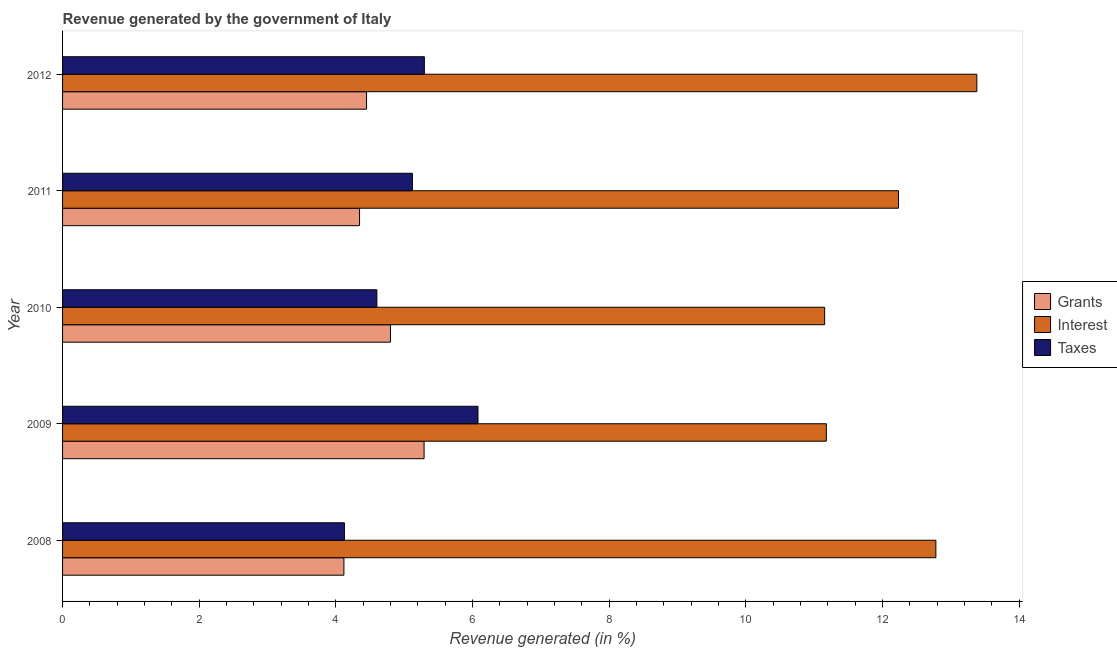How many different coloured bars are there?
Your response must be concise. 3. How many groups of bars are there?
Your response must be concise. 5. Are the number of bars on each tick of the Y-axis equal?
Offer a very short reply. Yes. How many bars are there on the 5th tick from the top?
Give a very brief answer. 3. What is the label of the 4th group of bars from the top?
Offer a very short reply. 2009. In how many cases, is the number of bars for a given year not equal to the number of legend labels?
Provide a succinct answer. 0. What is the percentage of revenue generated by interest in 2010?
Your response must be concise. 11.16. Across all years, what is the maximum percentage of revenue generated by interest?
Ensure brevity in your answer.  13.38. Across all years, what is the minimum percentage of revenue generated by interest?
Keep it short and to the point. 11.16. In which year was the percentage of revenue generated by interest maximum?
Offer a very short reply. 2012. What is the total percentage of revenue generated by grants in the graph?
Give a very brief answer. 23.01. What is the difference between the percentage of revenue generated by taxes in 2009 and that in 2012?
Ensure brevity in your answer.  0.79. What is the difference between the percentage of revenue generated by interest in 2010 and the percentage of revenue generated by taxes in 2008?
Offer a terse response. 7.03. What is the average percentage of revenue generated by grants per year?
Keep it short and to the point. 4.6. In the year 2010, what is the difference between the percentage of revenue generated by taxes and percentage of revenue generated by grants?
Your answer should be very brief. -0.2. What is the ratio of the percentage of revenue generated by interest in 2008 to that in 2012?
Offer a terse response. 0.95. Is the percentage of revenue generated by grants in 2008 less than that in 2012?
Your answer should be very brief. Yes. Is the difference between the percentage of revenue generated by interest in 2008 and 2011 greater than the difference between the percentage of revenue generated by taxes in 2008 and 2011?
Provide a succinct answer. Yes. What is the difference between the highest and the second highest percentage of revenue generated by taxes?
Provide a short and direct response. 0.79. What is the difference between the highest and the lowest percentage of revenue generated by interest?
Your response must be concise. 2.23. In how many years, is the percentage of revenue generated by grants greater than the average percentage of revenue generated by grants taken over all years?
Your response must be concise. 2. What does the 1st bar from the top in 2010 represents?
Ensure brevity in your answer.  Taxes. What does the 3rd bar from the bottom in 2009 represents?
Make the answer very short. Taxes. Is it the case that in every year, the sum of the percentage of revenue generated by grants and percentage of revenue generated by interest is greater than the percentage of revenue generated by taxes?
Your answer should be compact. Yes. Are the values on the major ticks of X-axis written in scientific E-notation?
Offer a very short reply. No. How are the legend labels stacked?
Provide a succinct answer. Vertical. What is the title of the graph?
Your answer should be very brief. Revenue generated by the government of Italy. What is the label or title of the X-axis?
Keep it short and to the point. Revenue generated (in %). What is the label or title of the Y-axis?
Provide a succinct answer. Year. What is the Revenue generated (in %) in Grants in 2008?
Offer a terse response. 4.12. What is the Revenue generated (in %) of Interest in 2008?
Your response must be concise. 12.78. What is the Revenue generated (in %) in Taxes in 2008?
Make the answer very short. 4.13. What is the Revenue generated (in %) in Grants in 2009?
Provide a succinct answer. 5.29. What is the Revenue generated (in %) in Interest in 2009?
Ensure brevity in your answer.  11.18. What is the Revenue generated (in %) in Taxes in 2009?
Your answer should be very brief. 6.08. What is the Revenue generated (in %) of Grants in 2010?
Ensure brevity in your answer.  4.8. What is the Revenue generated (in %) in Interest in 2010?
Provide a succinct answer. 11.16. What is the Revenue generated (in %) in Taxes in 2010?
Give a very brief answer. 4.6. What is the Revenue generated (in %) of Grants in 2011?
Give a very brief answer. 4.35. What is the Revenue generated (in %) in Interest in 2011?
Provide a short and direct response. 12.24. What is the Revenue generated (in %) of Taxes in 2011?
Your response must be concise. 5.12. What is the Revenue generated (in %) in Grants in 2012?
Offer a very short reply. 4.45. What is the Revenue generated (in %) of Interest in 2012?
Keep it short and to the point. 13.38. What is the Revenue generated (in %) of Taxes in 2012?
Ensure brevity in your answer.  5.3. Across all years, what is the maximum Revenue generated (in %) in Grants?
Provide a short and direct response. 5.29. Across all years, what is the maximum Revenue generated (in %) in Interest?
Ensure brevity in your answer.  13.38. Across all years, what is the maximum Revenue generated (in %) of Taxes?
Your answer should be very brief. 6.08. Across all years, what is the minimum Revenue generated (in %) in Grants?
Your response must be concise. 4.12. Across all years, what is the minimum Revenue generated (in %) in Interest?
Give a very brief answer. 11.16. Across all years, what is the minimum Revenue generated (in %) of Taxes?
Your answer should be very brief. 4.13. What is the total Revenue generated (in %) of Grants in the graph?
Your answer should be compact. 23.01. What is the total Revenue generated (in %) of Interest in the graph?
Keep it short and to the point. 60.74. What is the total Revenue generated (in %) of Taxes in the graph?
Make the answer very short. 25.22. What is the difference between the Revenue generated (in %) in Grants in 2008 and that in 2009?
Offer a very short reply. -1.17. What is the difference between the Revenue generated (in %) of Interest in 2008 and that in 2009?
Provide a succinct answer. 1.6. What is the difference between the Revenue generated (in %) of Taxes in 2008 and that in 2009?
Offer a terse response. -1.96. What is the difference between the Revenue generated (in %) in Grants in 2008 and that in 2010?
Your response must be concise. -0.68. What is the difference between the Revenue generated (in %) in Interest in 2008 and that in 2010?
Your answer should be compact. 1.63. What is the difference between the Revenue generated (in %) in Taxes in 2008 and that in 2010?
Provide a short and direct response. -0.48. What is the difference between the Revenue generated (in %) in Grants in 2008 and that in 2011?
Your response must be concise. -0.23. What is the difference between the Revenue generated (in %) of Interest in 2008 and that in 2011?
Ensure brevity in your answer.  0.55. What is the difference between the Revenue generated (in %) of Taxes in 2008 and that in 2011?
Your answer should be very brief. -1. What is the difference between the Revenue generated (in %) in Grants in 2008 and that in 2012?
Your answer should be compact. -0.33. What is the difference between the Revenue generated (in %) of Interest in 2008 and that in 2012?
Provide a succinct answer. -0.6. What is the difference between the Revenue generated (in %) of Taxes in 2008 and that in 2012?
Keep it short and to the point. -1.17. What is the difference between the Revenue generated (in %) in Grants in 2009 and that in 2010?
Keep it short and to the point. 0.49. What is the difference between the Revenue generated (in %) in Interest in 2009 and that in 2010?
Make the answer very short. 0.02. What is the difference between the Revenue generated (in %) in Taxes in 2009 and that in 2010?
Your answer should be very brief. 1.48. What is the difference between the Revenue generated (in %) in Grants in 2009 and that in 2011?
Provide a short and direct response. 0.94. What is the difference between the Revenue generated (in %) of Interest in 2009 and that in 2011?
Your answer should be compact. -1.06. What is the difference between the Revenue generated (in %) of Taxes in 2009 and that in 2011?
Provide a short and direct response. 0.96. What is the difference between the Revenue generated (in %) of Grants in 2009 and that in 2012?
Provide a short and direct response. 0.84. What is the difference between the Revenue generated (in %) in Interest in 2009 and that in 2012?
Ensure brevity in your answer.  -2.2. What is the difference between the Revenue generated (in %) of Taxes in 2009 and that in 2012?
Give a very brief answer. 0.79. What is the difference between the Revenue generated (in %) in Grants in 2010 and that in 2011?
Your response must be concise. 0.45. What is the difference between the Revenue generated (in %) of Interest in 2010 and that in 2011?
Your answer should be very brief. -1.08. What is the difference between the Revenue generated (in %) in Taxes in 2010 and that in 2011?
Provide a succinct answer. -0.52. What is the difference between the Revenue generated (in %) in Grants in 2010 and that in 2012?
Provide a short and direct response. 0.35. What is the difference between the Revenue generated (in %) of Interest in 2010 and that in 2012?
Offer a very short reply. -2.23. What is the difference between the Revenue generated (in %) in Taxes in 2010 and that in 2012?
Your answer should be compact. -0.69. What is the difference between the Revenue generated (in %) of Grants in 2011 and that in 2012?
Offer a very short reply. -0.1. What is the difference between the Revenue generated (in %) in Interest in 2011 and that in 2012?
Provide a succinct answer. -1.15. What is the difference between the Revenue generated (in %) in Taxes in 2011 and that in 2012?
Ensure brevity in your answer.  -0.17. What is the difference between the Revenue generated (in %) of Grants in 2008 and the Revenue generated (in %) of Interest in 2009?
Offer a very short reply. -7.06. What is the difference between the Revenue generated (in %) of Grants in 2008 and the Revenue generated (in %) of Taxes in 2009?
Provide a short and direct response. -1.96. What is the difference between the Revenue generated (in %) of Interest in 2008 and the Revenue generated (in %) of Taxes in 2009?
Keep it short and to the point. 6.7. What is the difference between the Revenue generated (in %) of Grants in 2008 and the Revenue generated (in %) of Interest in 2010?
Ensure brevity in your answer.  -7.04. What is the difference between the Revenue generated (in %) of Grants in 2008 and the Revenue generated (in %) of Taxes in 2010?
Give a very brief answer. -0.48. What is the difference between the Revenue generated (in %) in Interest in 2008 and the Revenue generated (in %) in Taxes in 2010?
Offer a terse response. 8.18. What is the difference between the Revenue generated (in %) of Grants in 2008 and the Revenue generated (in %) of Interest in 2011?
Offer a terse response. -8.12. What is the difference between the Revenue generated (in %) of Grants in 2008 and the Revenue generated (in %) of Taxes in 2011?
Your answer should be very brief. -1. What is the difference between the Revenue generated (in %) in Interest in 2008 and the Revenue generated (in %) in Taxes in 2011?
Provide a short and direct response. 7.66. What is the difference between the Revenue generated (in %) in Grants in 2008 and the Revenue generated (in %) in Interest in 2012?
Give a very brief answer. -9.26. What is the difference between the Revenue generated (in %) in Grants in 2008 and the Revenue generated (in %) in Taxes in 2012?
Your answer should be very brief. -1.18. What is the difference between the Revenue generated (in %) in Interest in 2008 and the Revenue generated (in %) in Taxes in 2012?
Make the answer very short. 7.49. What is the difference between the Revenue generated (in %) in Grants in 2009 and the Revenue generated (in %) in Interest in 2010?
Provide a succinct answer. -5.86. What is the difference between the Revenue generated (in %) in Grants in 2009 and the Revenue generated (in %) in Taxes in 2010?
Keep it short and to the point. 0.69. What is the difference between the Revenue generated (in %) in Interest in 2009 and the Revenue generated (in %) in Taxes in 2010?
Your response must be concise. 6.58. What is the difference between the Revenue generated (in %) of Grants in 2009 and the Revenue generated (in %) of Interest in 2011?
Your response must be concise. -6.94. What is the difference between the Revenue generated (in %) in Grants in 2009 and the Revenue generated (in %) in Taxes in 2011?
Give a very brief answer. 0.17. What is the difference between the Revenue generated (in %) of Interest in 2009 and the Revenue generated (in %) of Taxes in 2011?
Provide a succinct answer. 6.06. What is the difference between the Revenue generated (in %) of Grants in 2009 and the Revenue generated (in %) of Interest in 2012?
Offer a terse response. -8.09. What is the difference between the Revenue generated (in %) of Grants in 2009 and the Revenue generated (in %) of Taxes in 2012?
Make the answer very short. -0. What is the difference between the Revenue generated (in %) in Interest in 2009 and the Revenue generated (in %) in Taxes in 2012?
Provide a succinct answer. 5.88. What is the difference between the Revenue generated (in %) in Grants in 2010 and the Revenue generated (in %) in Interest in 2011?
Keep it short and to the point. -7.44. What is the difference between the Revenue generated (in %) in Grants in 2010 and the Revenue generated (in %) in Taxes in 2011?
Your answer should be compact. -0.32. What is the difference between the Revenue generated (in %) of Interest in 2010 and the Revenue generated (in %) of Taxes in 2011?
Ensure brevity in your answer.  6.03. What is the difference between the Revenue generated (in %) of Grants in 2010 and the Revenue generated (in %) of Interest in 2012?
Ensure brevity in your answer.  -8.58. What is the difference between the Revenue generated (in %) of Grants in 2010 and the Revenue generated (in %) of Taxes in 2012?
Offer a very short reply. -0.5. What is the difference between the Revenue generated (in %) of Interest in 2010 and the Revenue generated (in %) of Taxes in 2012?
Your answer should be very brief. 5.86. What is the difference between the Revenue generated (in %) of Grants in 2011 and the Revenue generated (in %) of Interest in 2012?
Your answer should be very brief. -9.04. What is the difference between the Revenue generated (in %) of Grants in 2011 and the Revenue generated (in %) of Taxes in 2012?
Ensure brevity in your answer.  -0.95. What is the difference between the Revenue generated (in %) of Interest in 2011 and the Revenue generated (in %) of Taxes in 2012?
Your answer should be very brief. 6.94. What is the average Revenue generated (in %) of Grants per year?
Provide a succinct answer. 4.6. What is the average Revenue generated (in %) of Interest per year?
Offer a terse response. 12.15. What is the average Revenue generated (in %) of Taxes per year?
Keep it short and to the point. 5.04. In the year 2008, what is the difference between the Revenue generated (in %) in Grants and Revenue generated (in %) in Interest?
Offer a very short reply. -8.66. In the year 2008, what is the difference between the Revenue generated (in %) in Grants and Revenue generated (in %) in Taxes?
Your response must be concise. -0.01. In the year 2008, what is the difference between the Revenue generated (in %) of Interest and Revenue generated (in %) of Taxes?
Keep it short and to the point. 8.66. In the year 2009, what is the difference between the Revenue generated (in %) of Grants and Revenue generated (in %) of Interest?
Offer a very short reply. -5.89. In the year 2009, what is the difference between the Revenue generated (in %) in Grants and Revenue generated (in %) in Taxes?
Ensure brevity in your answer.  -0.79. In the year 2009, what is the difference between the Revenue generated (in %) in Interest and Revenue generated (in %) in Taxes?
Provide a short and direct response. 5.1. In the year 2010, what is the difference between the Revenue generated (in %) of Grants and Revenue generated (in %) of Interest?
Your answer should be very brief. -6.36. In the year 2010, what is the difference between the Revenue generated (in %) in Grants and Revenue generated (in %) in Taxes?
Provide a short and direct response. 0.2. In the year 2010, what is the difference between the Revenue generated (in %) of Interest and Revenue generated (in %) of Taxes?
Your answer should be compact. 6.55. In the year 2011, what is the difference between the Revenue generated (in %) of Grants and Revenue generated (in %) of Interest?
Your answer should be compact. -7.89. In the year 2011, what is the difference between the Revenue generated (in %) of Grants and Revenue generated (in %) of Taxes?
Your answer should be very brief. -0.77. In the year 2011, what is the difference between the Revenue generated (in %) in Interest and Revenue generated (in %) in Taxes?
Your answer should be compact. 7.12. In the year 2012, what is the difference between the Revenue generated (in %) in Grants and Revenue generated (in %) in Interest?
Keep it short and to the point. -8.93. In the year 2012, what is the difference between the Revenue generated (in %) in Grants and Revenue generated (in %) in Taxes?
Give a very brief answer. -0.85. In the year 2012, what is the difference between the Revenue generated (in %) of Interest and Revenue generated (in %) of Taxes?
Your answer should be compact. 8.09. What is the ratio of the Revenue generated (in %) of Grants in 2008 to that in 2009?
Ensure brevity in your answer.  0.78. What is the ratio of the Revenue generated (in %) of Interest in 2008 to that in 2009?
Keep it short and to the point. 1.14. What is the ratio of the Revenue generated (in %) of Taxes in 2008 to that in 2009?
Your answer should be compact. 0.68. What is the ratio of the Revenue generated (in %) in Grants in 2008 to that in 2010?
Give a very brief answer. 0.86. What is the ratio of the Revenue generated (in %) in Interest in 2008 to that in 2010?
Make the answer very short. 1.15. What is the ratio of the Revenue generated (in %) of Taxes in 2008 to that in 2010?
Your response must be concise. 0.9. What is the ratio of the Revenue generated (in %) in Interest in 2008 to that in 2011?
Your answer should be compact. 1.04. What is the ratio of the Revenue generated (in %) of Taxes in 2008 to that in 2011?
Give a very brief answer. 0.81. What is the ratio of the Revenue generated (in %) in Grants in 2008 to that in 2012?
Your answer should be very brief. 0.93. What is the ratio of the Revenue generated (in %) in Interest in 2008 to that in 2012?
Your response must be concise. 0.96. What is the ratio of the Revenue generated (in %) of Taxes in 2008 to that in 2012?
Ensure brevity in your answer.  0.78. What is the ratio of the Revenue generated (in %) of Grants in 2009 to that in 2010?
Give a very brief answer. 1.1. What is the ratio of the Revenue generated (in %) of Taxes in 2009 to that in 2010?
Provide a short and direct response. 1.32. What is the ratio of the Revenue generated (in %) in Grants in 2009 to that in 2011?
Your answer should be very brief. 1.22. What is the ratio of the Revenue generated (in %) in Interest in 2009 to that in 2011?
Keep it short and to the point. 0.91. What is the ratio of the Revenue generated (in %) of Taxes in 2009 to that in 2011?
Your response must be concise. 1.19. What is the ratio of the Revenue generated (in %) of Grants in 2009 to that in 2012?
Offer a very short reply. 1.19. What is the ratio of the Revenue generated (in %) of Interest in 2009 to that in 2012?
Give a very brief answer. 0.84. What is the ratio of the Revenue generated (in %) of Taxes in 2009 to that in 2012?
Your response must be concise. 1.15. What is the ratio of the Revenue generated (in %) in Grants in 2010 to that in 2011?
Make the answer very short. 1.1. What is the ratio of the Revenue generated (in %) of Interest in 2010 to that in 2011?
Ensure brevity in your answer.  0.91. What is the ratio of the Revenue generated (in %) in Taxes in 2010 to that in 2011?
Your response must be concise. 0.9. What is the ratio of the Revenue generated (in %) in Grants in 2010 to that in 2012?
Give a very brief answer. 1.08. What is the ratio of the Revenue generated (in %) of Interest in 2010 to that in 2012?
Your answer should be compact. 0.83. What is the ratio of the Revenue generated (in %) in Taxes in 2010 to that in 2012?
Offer a terse response. 0.87. What is the ratio of the Revenue generated (in %) in Grants in 2011 to that in 2012?
Your answer should be compact. 0.98. What is the ratio of the Revenue generated (in %) in Interest in 2011 to that in 2012?
Offer a very short reply. 0.91. What is the difference between the highest and the second highest Revenue generated (in %) of Grants?
Your response must be concise. 0.49. What is the difference between the highest and the second highest Revenue generated (in %) of Interest?
Keep it short and to the point. 0.6. What is the difference between the highest and the second highest Revenue generated (in %) in Taxes?
Ensure brevity in your answer.  0.79. What is the difference between the highest and the lowest Revenue generated (in %) of Grants?
Provide a succinct answer. 1.17. What is the difference between the highest and the lowest Revenue generated (in %) of Interest?
Provide a short and direct response. 2.23. What is the difference between the highest and the lowest Revenue generated (in %) of Taxes?
Keep it short and to the point. 1.96. 